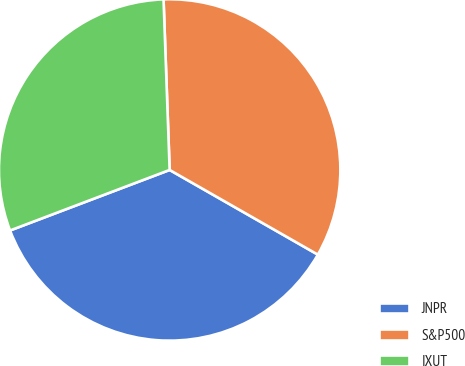<chart> <loc_0><loc_0><loc_500><loc_500><pie_chart><fcel>JNPR<fcel>S&P500<fcel>IXUT<nl><fcel>35.97%<fcel>33.83%<fcel>30.2%<nl></chart> 